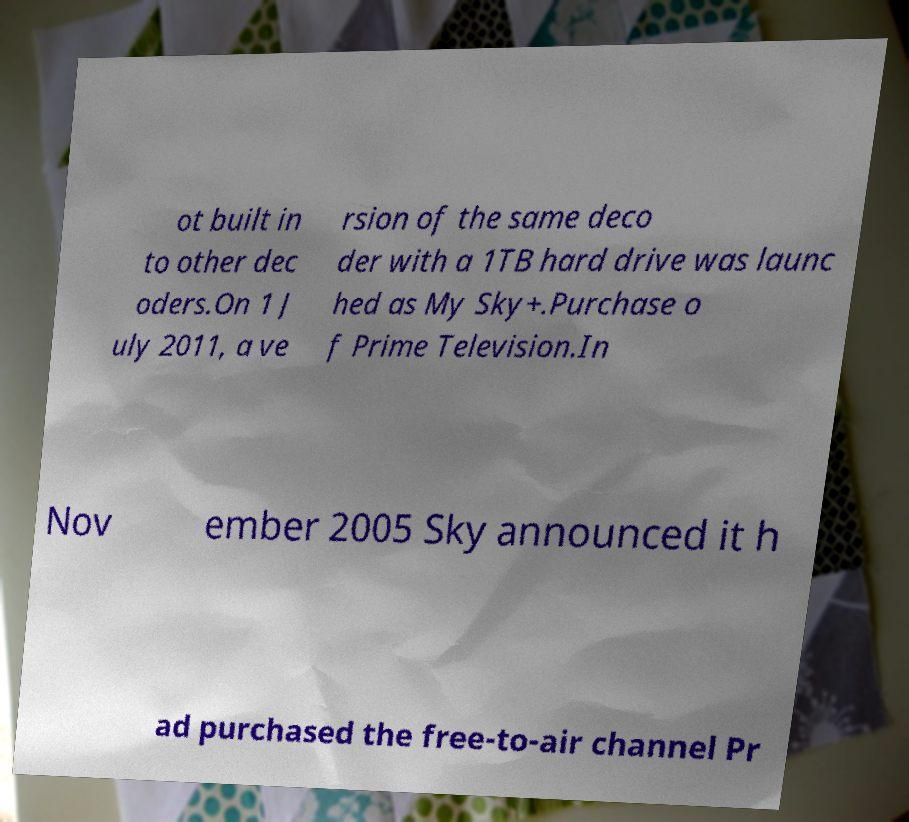Could you extract and type out the text from this image? ot built in to other dec oders.On 1 J uly 2011, a ve rsion of the same deco der with a 1TB hard drive was launc hed as My Sky+.Purchase o f Prime Television.In Nov ember 2005 Sky announced it h ad purchased the free-to-air channel Pr 